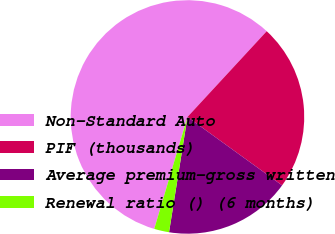Convert chart to OTSL. <chart><loc_0><loc_0><loc_500><loc_500><pie_chart><fcel>Non-Standard Auto<fcel>PIF (thousands)<fcel>Average premium-gross written<fcel>Renewal ratio () (6 months)<nl><fcel>57.28%<fcel>23.09%<fcel>17.56%<fcel>2.07%<nl></chart> 